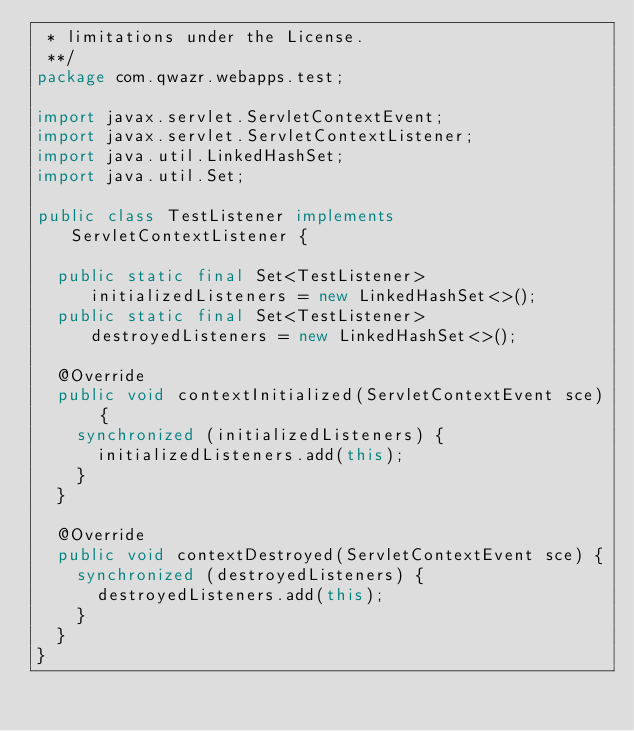<code> <loc_0><loc_0><loc_500><loc_500><_Java_> * limitations under the License.
 **/
package com.qwazr.webapps.test;

import javax.servlet.ServletContextEvent;
import javax.servlet.ServletContextListener;
import java.util.LinkedHashSet;
import java.util.Set;

public class TestListener implements ServletContextListener {

	public static final Set<TestListener> initializedListeners = new LinkedHashSet<>();
	public static final Set<TestListener> destroyedListeners = new LinkedHashSet<>();

	@Override
	public void contextInitialized(ServletContextEvent sce) {
		synchronized (initializedListeners) {
			initializedListeners.add(this);
		}
	}

	@Override
	public void contextDestroyed(ServletContextEvent sce) {
		synchronized (destroyedListeners) {
			destroyedListeners.add(this);
		}
	}
}</code> 